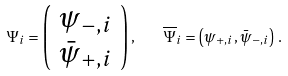Convert formula to latex. <formula><loc_0><loc_0><loc_500><loc_500>\Psi _ { i } = \left ( \begin{array} { l } { { \psi _ { - , i } } } \\ { { \bar { \psi } _ { + , i } } } \end{array} \right ) , \quad \overline { \Psi } _ { i } = \left ( \psi _ { + , i } , \bar { \psi } _ { - , i } \right ) \, .</formula> 